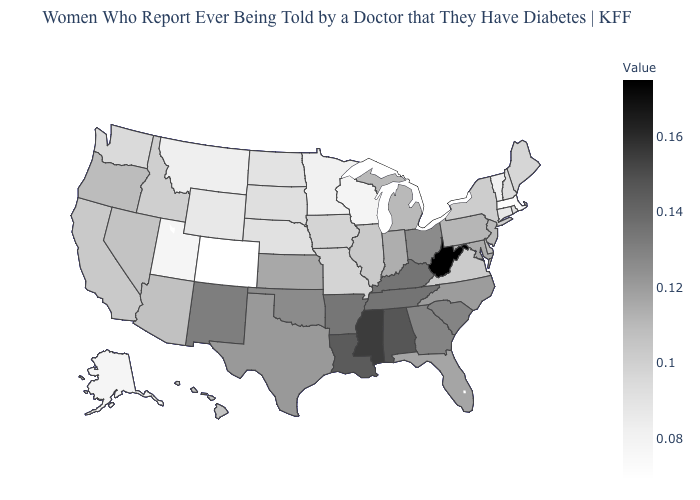Among the states that border Missouri , which have the lowest value?
Write a very short answer. Nebraska. Which states have the highest value in the USA?
Short answer required. West Virginia. Which states have the lowest value in the West?
Concise answer only. Colorado. Is the legend a continuous bar?
Concise answer only. Yes. Which states have the highest value in the USA?
Be succinct. West Virginia. Does Arkansas have the highest value in the USA?
Answer briefly. No. Does New Mexico have the highest value in the West?
Be succinct. Yes. 